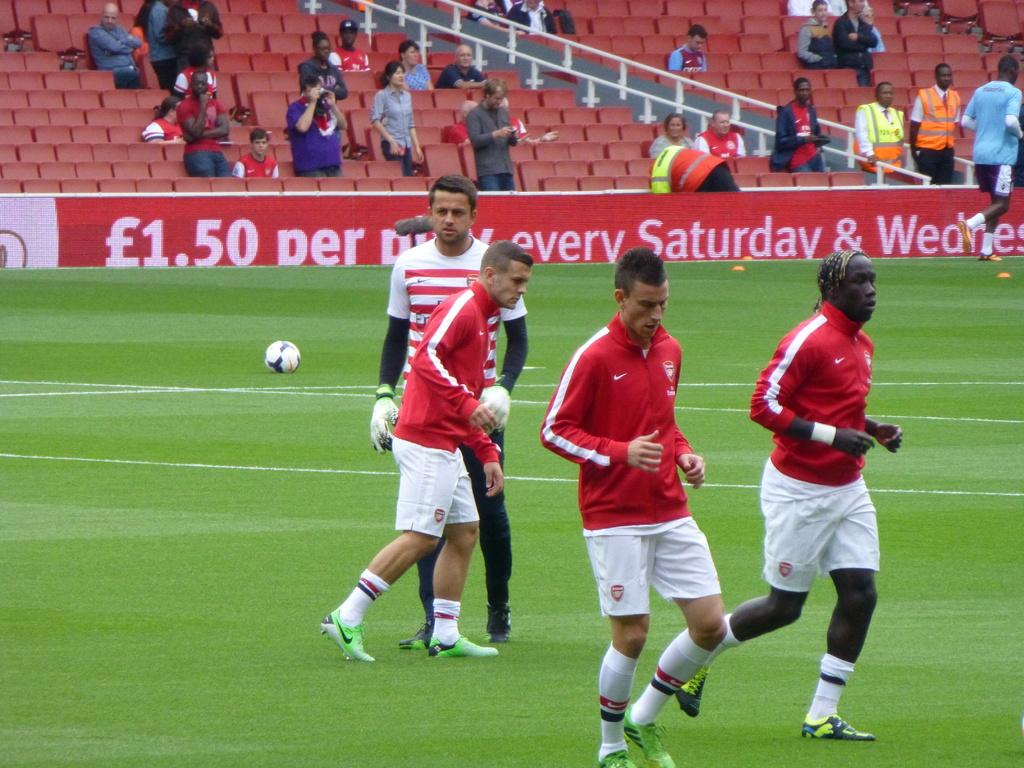Provide a one-sentence caption for the provided image. The advertisement bordering a soccer field promises a certain price on Saturdays and Wednesdays. 